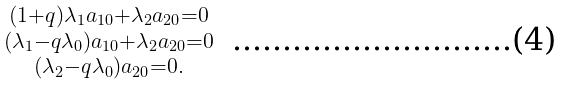Convert formula to latex. <formula><loc_0><loc_0><loc_500><loc_500>\begin{smallmatrix} ( 1 + q ) \lambda _ { 1 } a _ { 1 0 } + \lambda _ { 2 } a _ { 2 0 } = 0 \\ ( \lambda _ { 1 } - q \lambda _ { 0 } ) a _ { 1 0 } + \lambda _ { 2 } a _ { 2 0 } = 0 \\ ( \lambda _ { 2 } - q \lambda _ { 0 } ) a _ { 2 0 } = 0 . \\ \end{smallmatrix}</formula> 